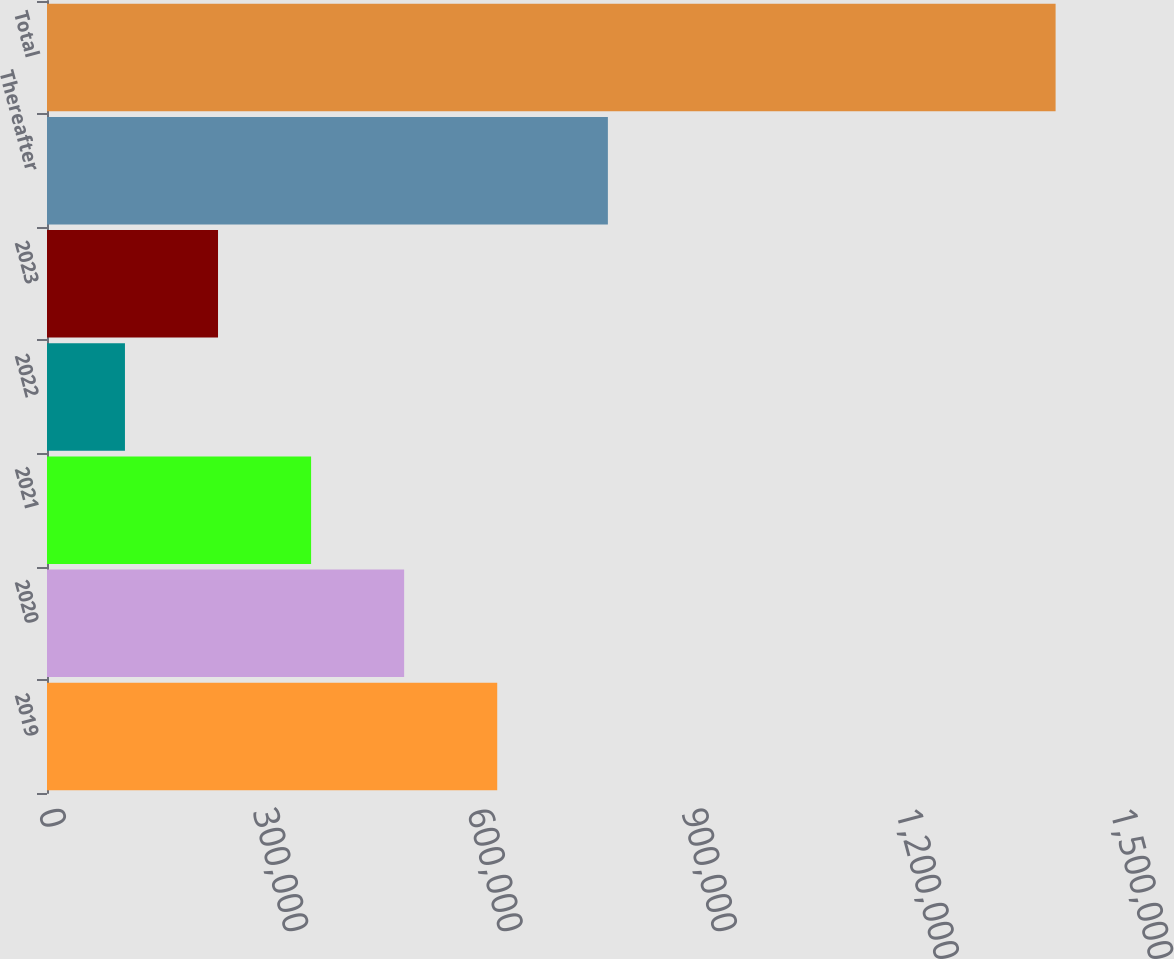<chart> <loc_0><loc_0><loc_500><loc_500><bar_chart><fcel>2019<fcel>2020<fcel>2021<fcel>2022<fcel>2023<fcel>Thereafter<fcel>Total<nl><fcel>629965<fcel>499744<fcel>369524<fcel>109083<fcel>239303<fcel>784817<fcel>1.41129e+06<nl></chart> 